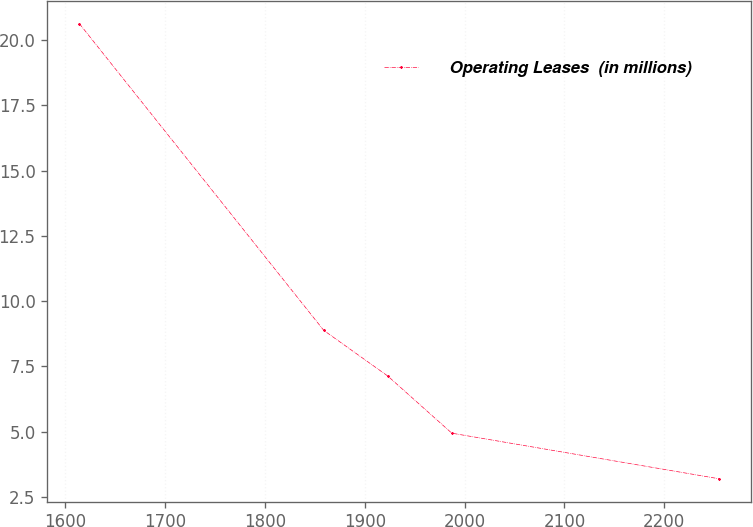<chart> <loc_0><loc_0><loc_500><loc_500><line_chart><ecel><fcel>Operating Leases  (in millions)<nl><fcel>1614.1<fcel>20.64<nl><fcel>1858.96<fcel>8.88<nl><fcel>1923.08<fcel>7.13<nl><fcel>1987.2<fcel>4.94<nl><fcel>2255.31<fcel>3.19<nl></chart> 